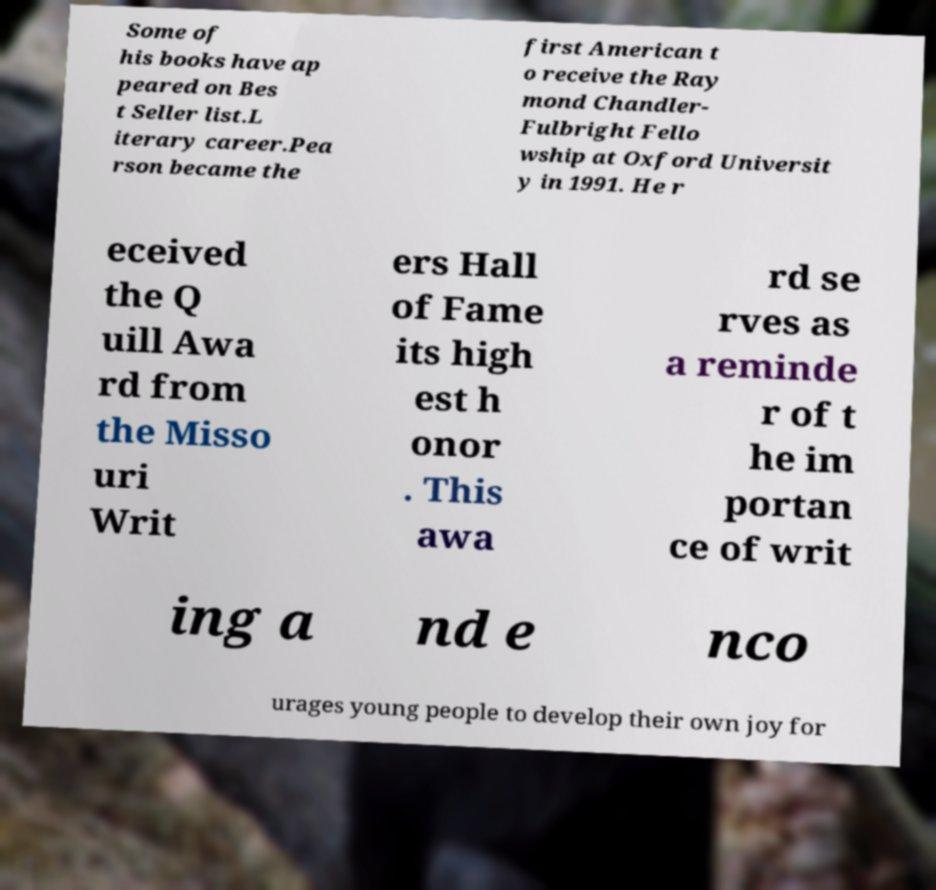Please read and relay the text visible in this image. What does it say? Some of his books have ap peared on Bes t Seller list.L iterary career.Pea rson became the first American t o receive the Ray mond Chandler- Fulbright Fello wship at Oxford Universit y in 1991. He r eceived the Q uill Awa rd from the Misso uri Writ ers Hall of Fame its high est h onor . This awa rd se rves as a reminde r of t he im portan ce of writ ing a nd e nco urages young people to develop their own joy for 